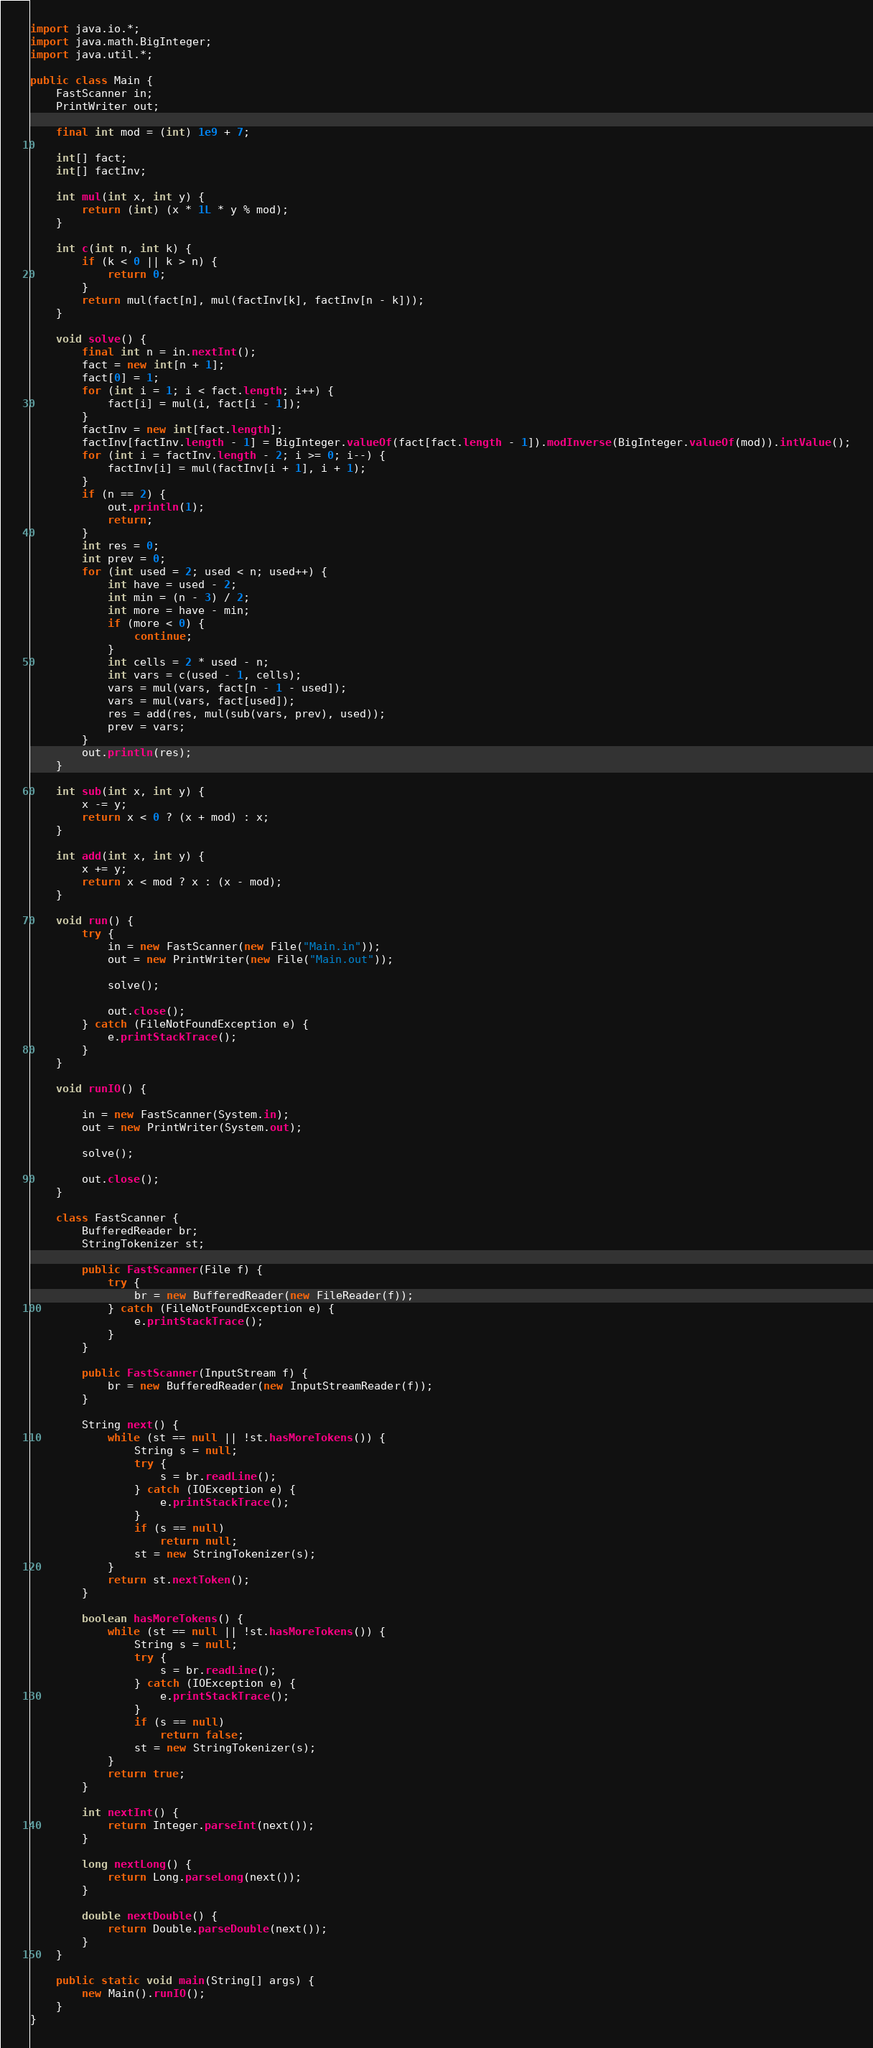<code> <loc_0><loc_0><loc_500><loc_500><_Java_>import java.io.*;
import java.math.BigInteger;
import java.util.*;

public class Main {
    FastScanner in;
    PrintWriter out;

    final int mod = (int) 1e9 + 7;

    int[] fact;
    int[] factInv;

    int mul(int x, int y) {
        return (int) (x * 1L * y % mod);
    }

    int c(int n, int k) {
        if (k < 0 || k > n) {
            return 0;
        }
        return mul(fact[n], mul(factInv[k], factInv[n - k]));
    }

    void solve() {
        final int n = in.nextInt();
        fact = new int[n + 1];
        fact[0] = 1;
        for (int i = 1; i < fact.length; i++) {
            fact[i] = mul(i, fact[i - 1]);
        }
        factInv = new int[fact.length];
        factInv[factInv.length - 1] = BigInteger.valueOf(fact[fact.length - 1]).modInverse(BigInteger.valueOf(mod)).intValue();
        for (int i = factInv.length - 2; i >= 0; i--) {
            factInv[i] = mul(factInv[i + 1], i + 1);
        }
        if (n == 2) {
            out.println(1);
            return;
        }
        int res = 0;
        int prev = 0;
        for (int used = 2; used < n; used++) {
            int have = used - 2;
            int min = (n - 3) / 2;
            int more = have - min;
            if (more < 0) {
                continue;
            }
            int cells = 2 * used - n;
            int vars = c(used - 1, cells);
            vars = mul(vars, fact[n - 1 - used]);
            vars = mul(vars, fact[used]);
            res = add(res, mul(sub(vars, prev), used));
            prev = vars;
        }
        out.println(res);
    }

    int sub(int x, int y) {
        x -= y;
        return x < 0 ? (x + mod) : x;
    }

    int add(int x, int y) {
        x += y;
        return x < mod ? x : (x - mod);
    }

    void run() {
        try {
            in = new FastScanner(new File("Main.in"));
            out = new PrintWriter(new File("Main.out"));

            solve();

            out.close();
        } catch (FileNotFoundException e) {
            e.printStackTrace();
        }
    }

    void runIO() {

        in = new FastScanner(System.in);
        out = new PrintWriter(System.out);

        solve();

        out.close();
    }

    class FastScanner {
        BufferedReader br;
        StringTokenizer st;

        public FastScanner(File f) {
            try {
                br = new BufferedReader(new FileReader(f));
            } catch (FileNotFoundException e) {
                e.printStackTrace();
            }
        }

        public FastScanner(InputStream f) {
            br = new BufferedReader(new InputStreamReader(f));
        }

        String next() {
            while (st == null || !st.hasMoreTokens()) {
                String s = null;
                try {
                    s = br.readLine();
                } catch (IOException e) {
                    e.printStackTrace();
                }
                if (s == null)
                    return null;
                st = new StringTokenizer(s);
            }
            return st.nextToken();
        }

        boolean hasMoreTokens() {
            while (st == null || !st.hasMoreTokens()) {
                String s = null;
                try {
                    s = br.readLine();
                } catch (IOException e) {
                    e.printStackTrace();
                }
                if (s == null)
                    return false;
                st = new StringTokenizer(s);
            }
            return true;
        }

        int nextInt() {
            return Integer.parseInt(next());
        }

        long nextLong() {
            return Long.parseLong(next());
        }

        double nextDouble() {
            return Double.parseDouble(next());
        }
    }

    public static void main(String[] args) {
        new Main().runIO();
    }
}</code> 